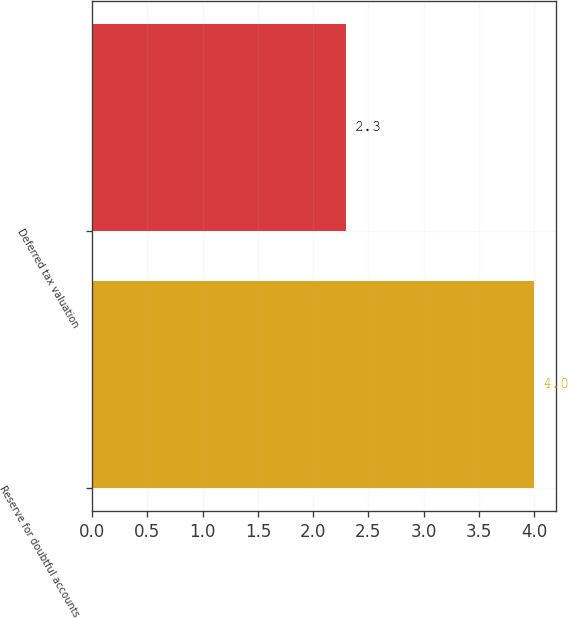Convert chart. <chart><loc_0><loc_0><loc_500><loc_500><bar_chart><fcel>Reserve for doubtful accounts<fcel>Deferred tax valuation<nl><fcel>4<fcel>2.3<nl></chart> 